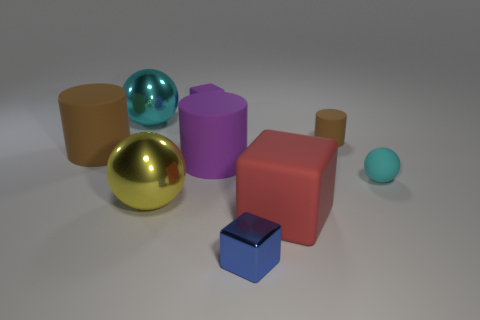What number of yellow balls have the same material as the blue thing?
Your response must be concise. 1. The other metallic thing that is the same shape as the yellow metallic thing is what size?
Make the answer very short. Large. What is the material of the large red object?
Provide a short and direct response. Rubber. What is the material of the purple thing behind the large matte object that is on the left side of the cylinder in front of the large brown matte cylinder?
Your response must be concise. Rubber. Is there anything else that has the same shape as the big brown thing?
Offer a very short reply. Yes. What is the color of the small rubber object that is the same shape as the large red thing?
Provide a succinct answer. Purple. There is a rubber cube to the right of the blue block; does it have the same color as the cylinder on the right side of the tiny blue thing?
Give a very brief answer. No. Are there more large metal spheres in front of the small cyan matte sphere than blue shiny things?
Provide a succinct answer. No. How many other things are the same size as the purple cylinder?
Ensure brevity in your answer.  4. How many objects are right of the big purple matte cylinder and in front of the tiny cyan object?
Give a very brief answer. 2. 